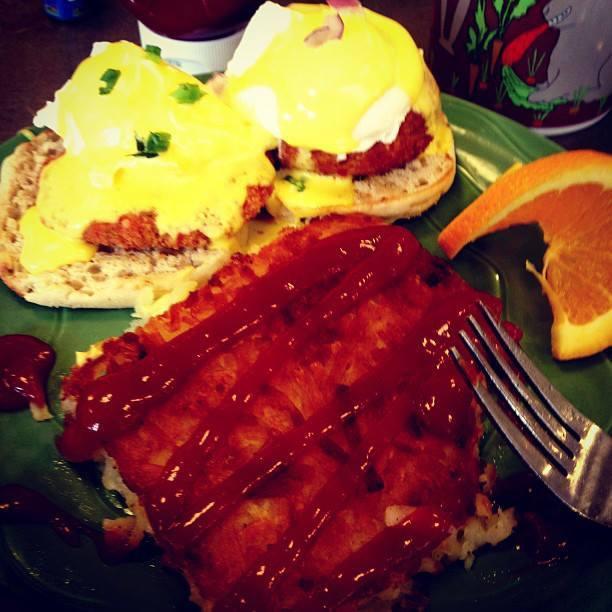How many sandwiches can you see?
Give a very brief answer. 3. How many giraffes are there?
Give a very brief answer. 0. 